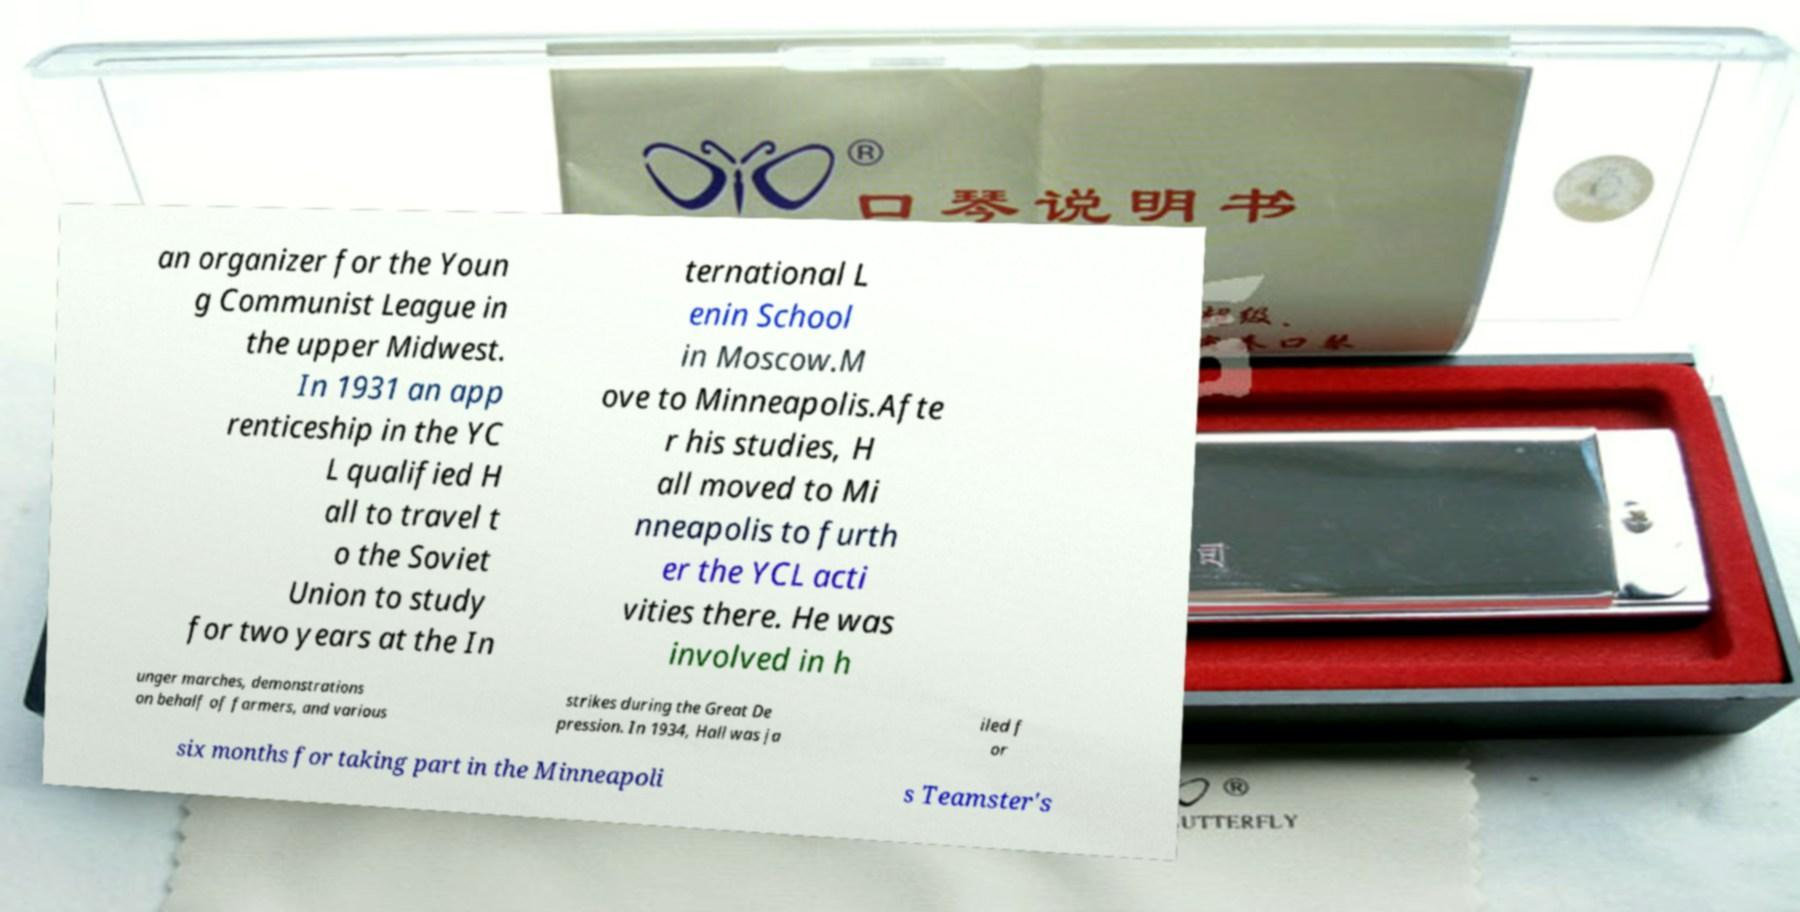For documentation purposes, I need the text within this image transcribed. Could you provide that? an organizer for the Youn g Communist League in the upper Midwest. In 1931 an app renticeship in the YC L qualified H all to travel t o the Soviet Union to study for two years at the In ternational L enin School in Moscow.M ove to Minneapolis.Afte r his studies, H all moved to Mi nneapolis to furth er the YCL acti vities there. He was involved in h unger marches, demonstrations on behalf of farmers, and various strikes during the Great De pression. In 1934, Hall was ja iled f or six months for taking part in the Minneapoli s Teamster's 